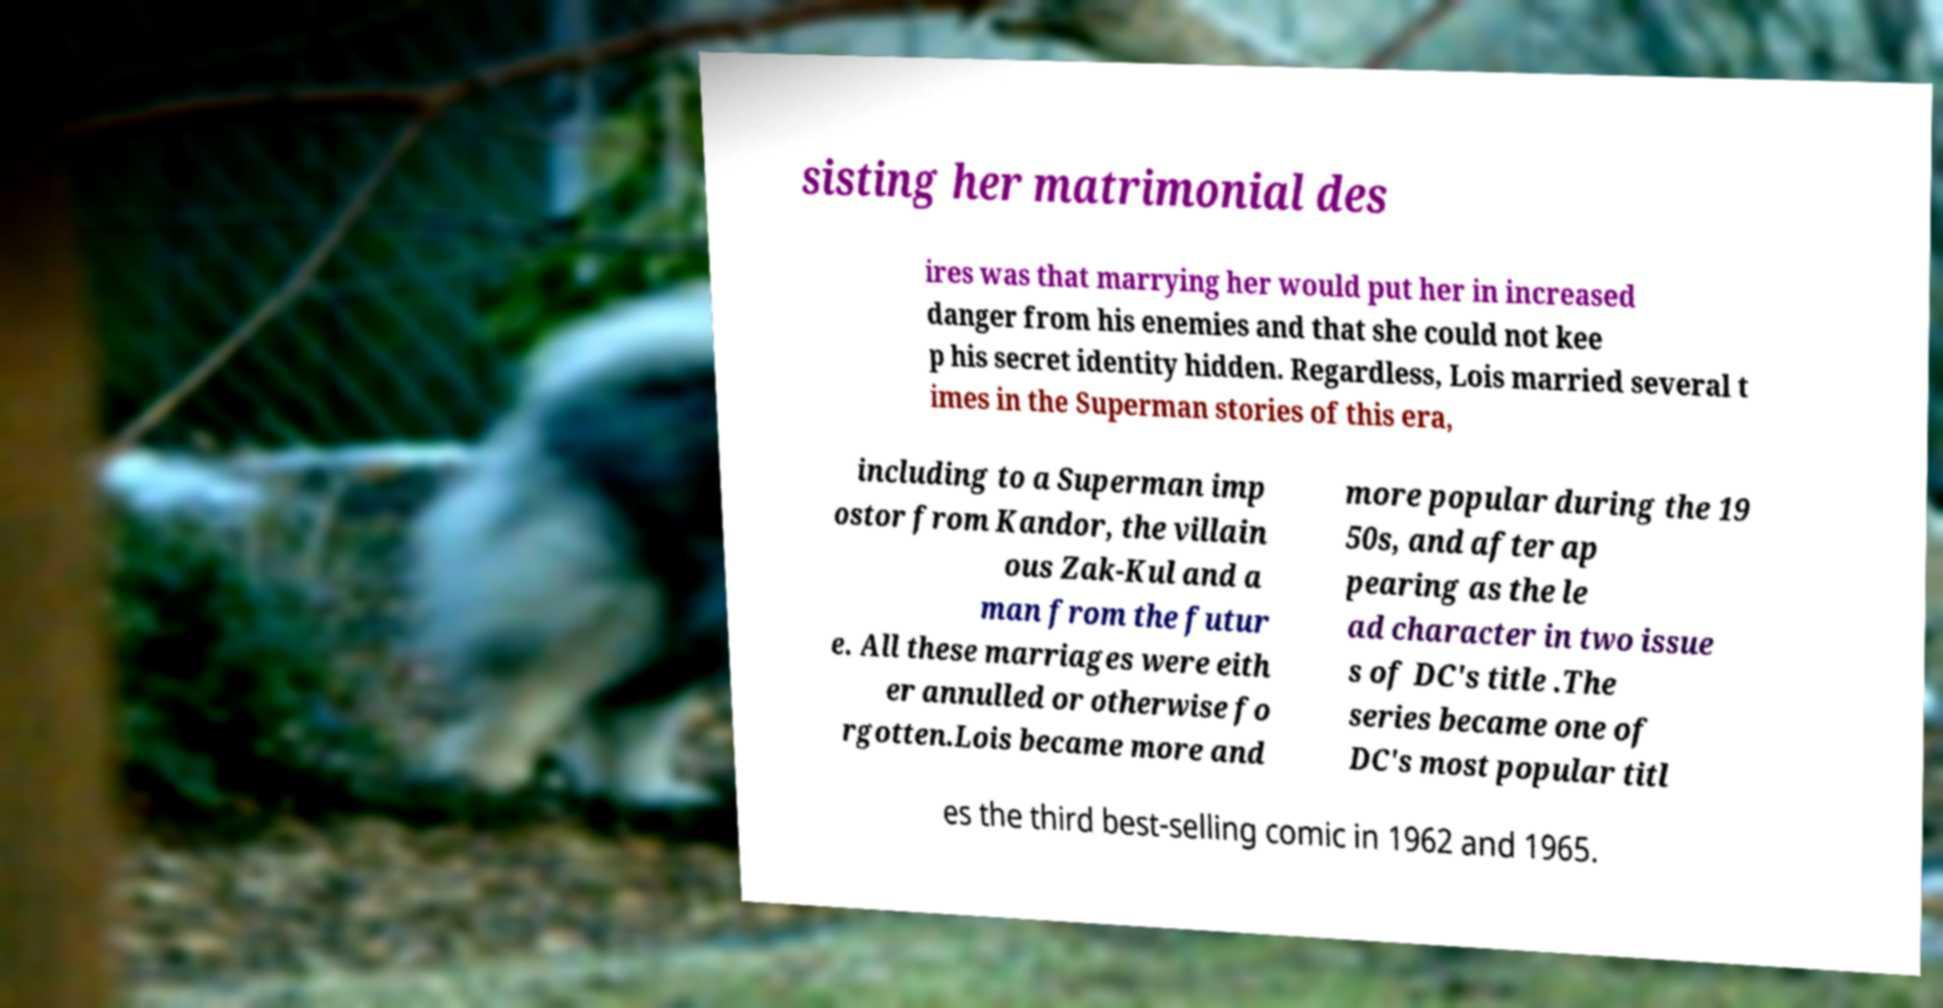Please identify and transcribe the text found in this image. sisting her matrimonial des ires was that marrying her would put her in increased danger from his enemies and that she could not kee p his secret identity hidden. Regardless, Lois married several t imes in the Superman stories of this era, including to a Superman imp ostor from Kandor, the villain ous Zak-Kul and a man from the futur e. All these marriages were eith er annulled or otherwise fo rgotten.Lois became more and more popular during the 19 50s, and after ap pearing as the le ad character in two issue s of DC's title .The series became one of DC's most popular titl es the third best-selling comic in 1962 and 1965. 